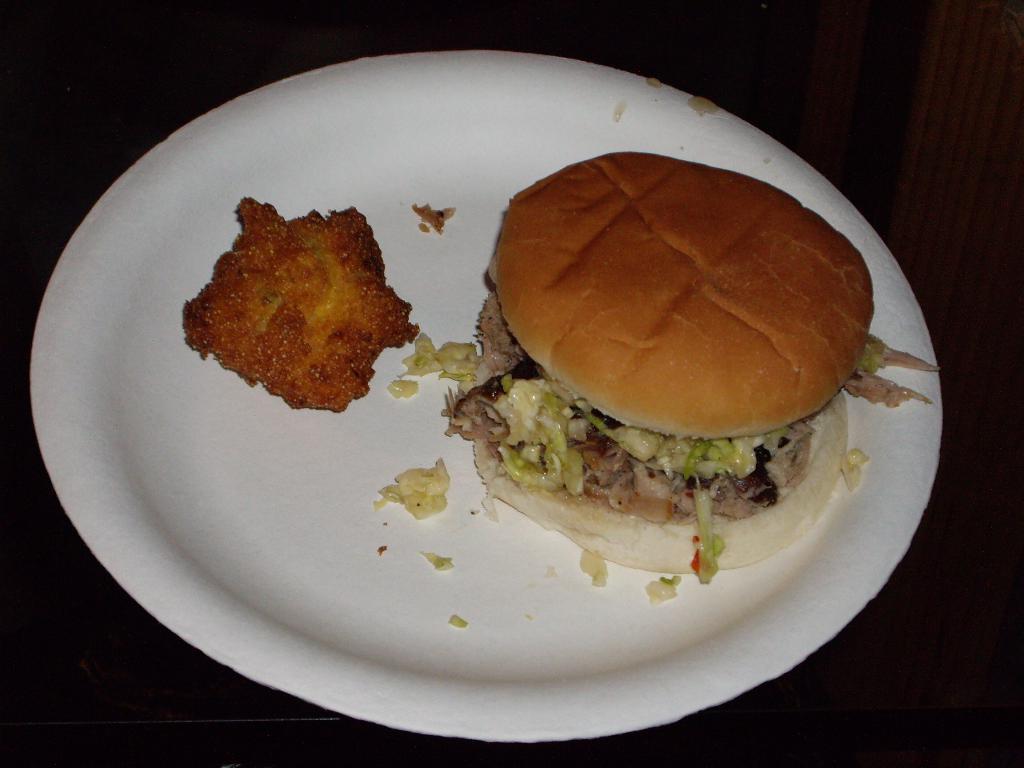Please provide a concise description of this image. In this picture we can see a plate, there is a burger and some food present in this place, we can see a dark background. 